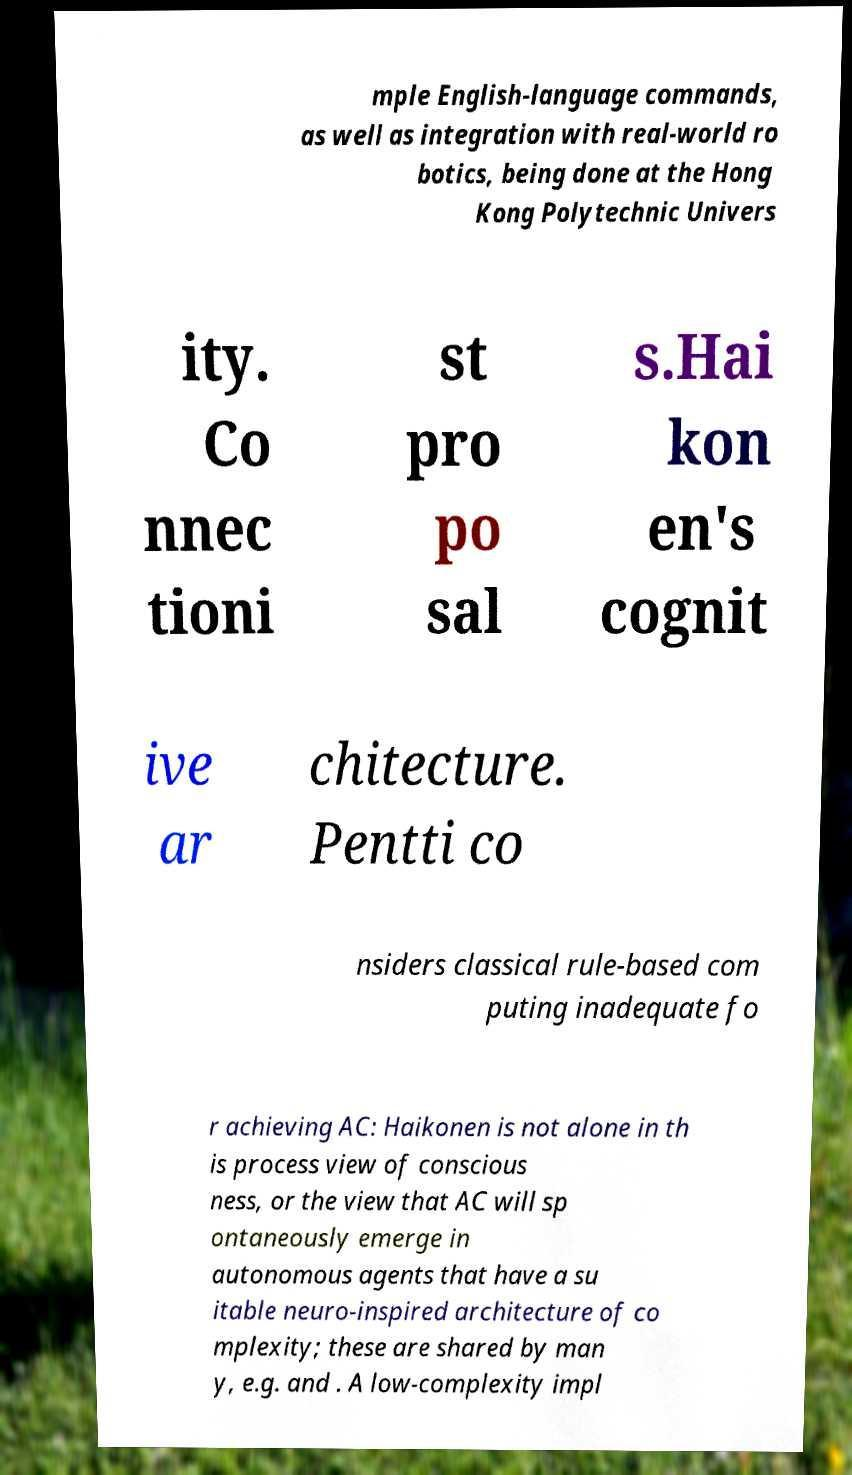Could you assist in decoding the text presented in this image and type it out clearly? mple English-language commands, as well as integration with real-world ro botics, being done at the Hong Kong Polytechnic Univers ity. Co nnec tioni st pro po sal s.Hai kon en's cognit ive ar chitecture. Pentti co nsiders classical rule-based com puting inadequate fo r achieving AC: Haikonen is not alone in th is process view of conscious ness, or the view that AC will sp ontaneously emerge in autonomous agents that have a su itable neuro-inspired architecture of co mplexity; these are shared by man y, e.g. and . A low-complexity impl 